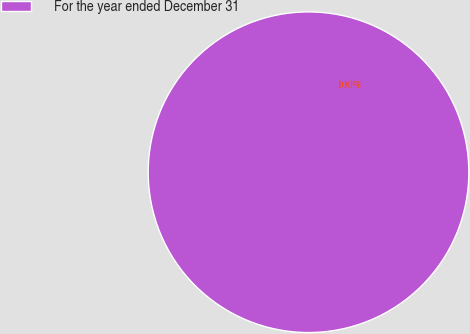Convert chart to OTSL. <chart><loc_0><loc_0><loc_500><loc_500><pie_chart><fcel>For the year ended December 31<nl><fcel>100.0%<nl></chart> 